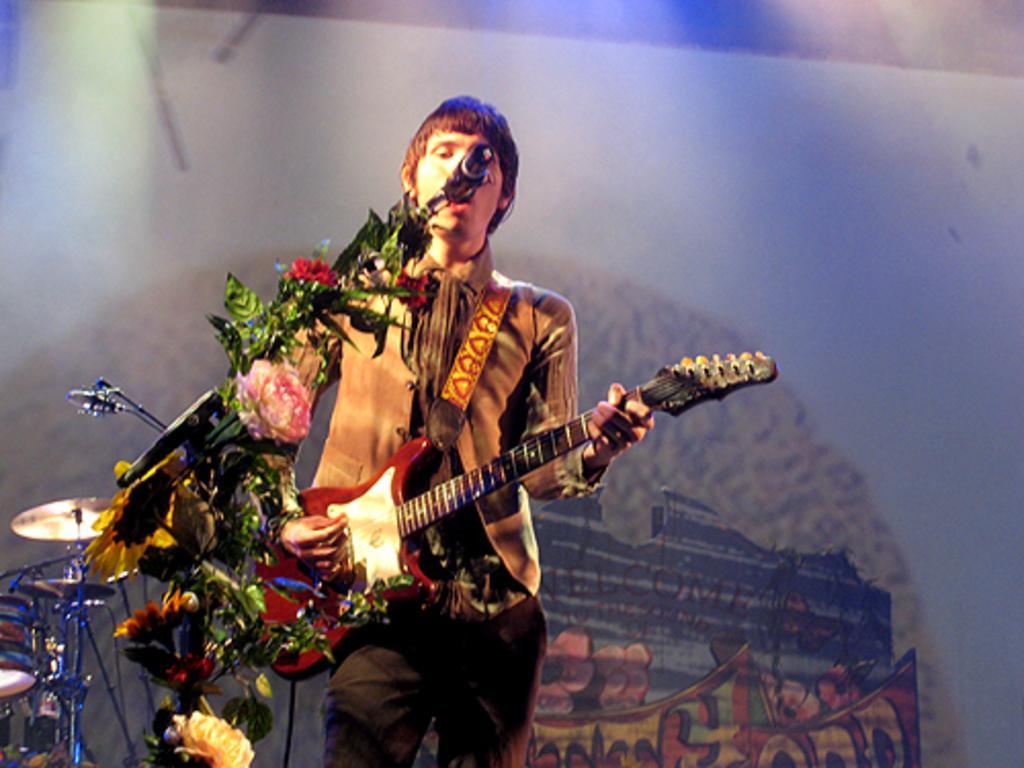In one or two sentences, can you explain what this image depicts? In this image I can see a person standing and playing the guitar and also it seems like he's singing a song. In front of this person there is a mike stand decorated with flowers. On the left side of the image I can see drums. 